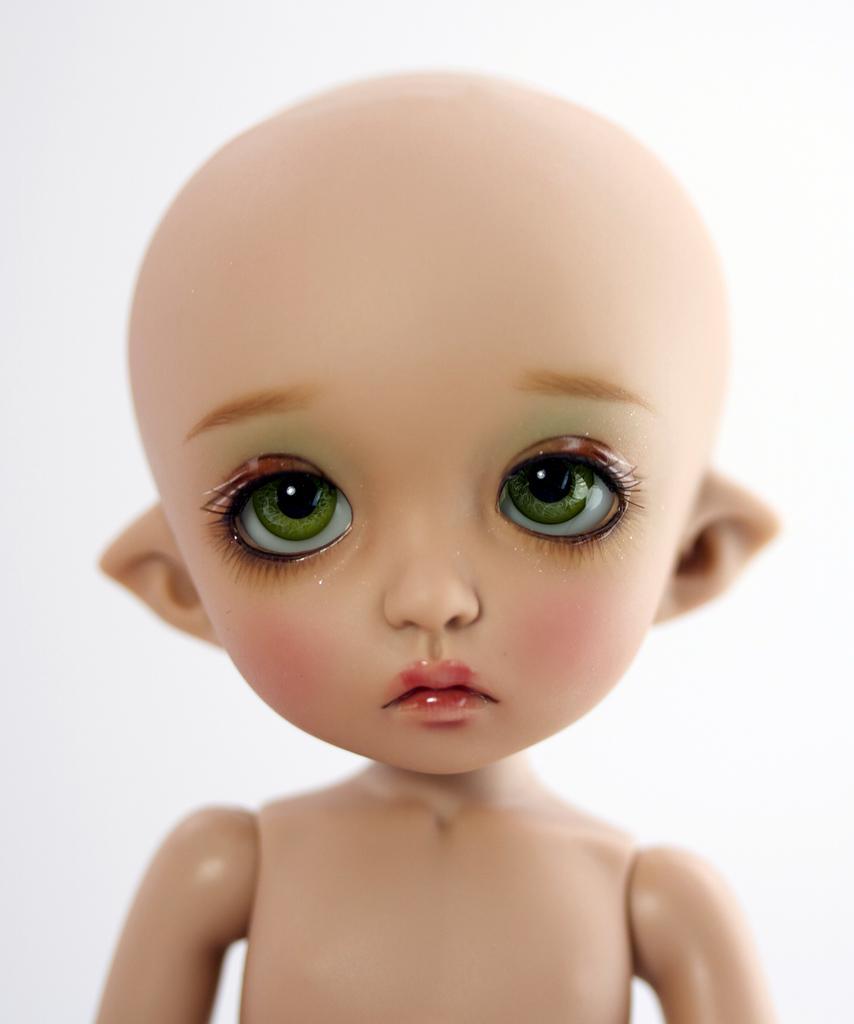In one or two sentences, can you explain what this image depicts? In this image I see the depiction of a baby and I see that it is totally white in the background. 